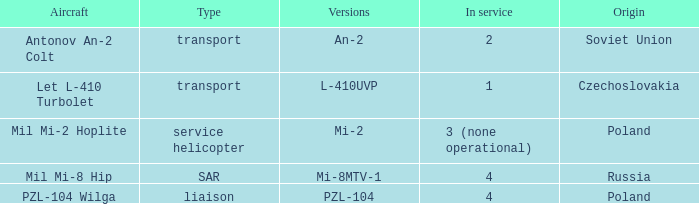Tell me the aircraft for pzl-104 PZL-104 Wilga. Help me parse the entirety of this table. {'header': ['Aircraft', 'Type', 'Versions', 'In service', 'Origin'], 'rows': [['Antonov An-2 Colt', 'transport', 'An-2', '2', 'Soviet Union'], ['Let L-410 Turbolet', 'transport', 'L-410UVP', '1', 'Czechoslovakia'], ['Mil Mi-2 Hoplite', 'service helicopter', 'Mi-2', '3 (none operational)', 'Poland'], ['Mil Mi-8 Hip', 'SAR', 'Mi-8MTV-1', '4', 'Russia'], ['PZL-104 Wilga', 'liaison', 'PZL-104', '4', 'Poland']]} 